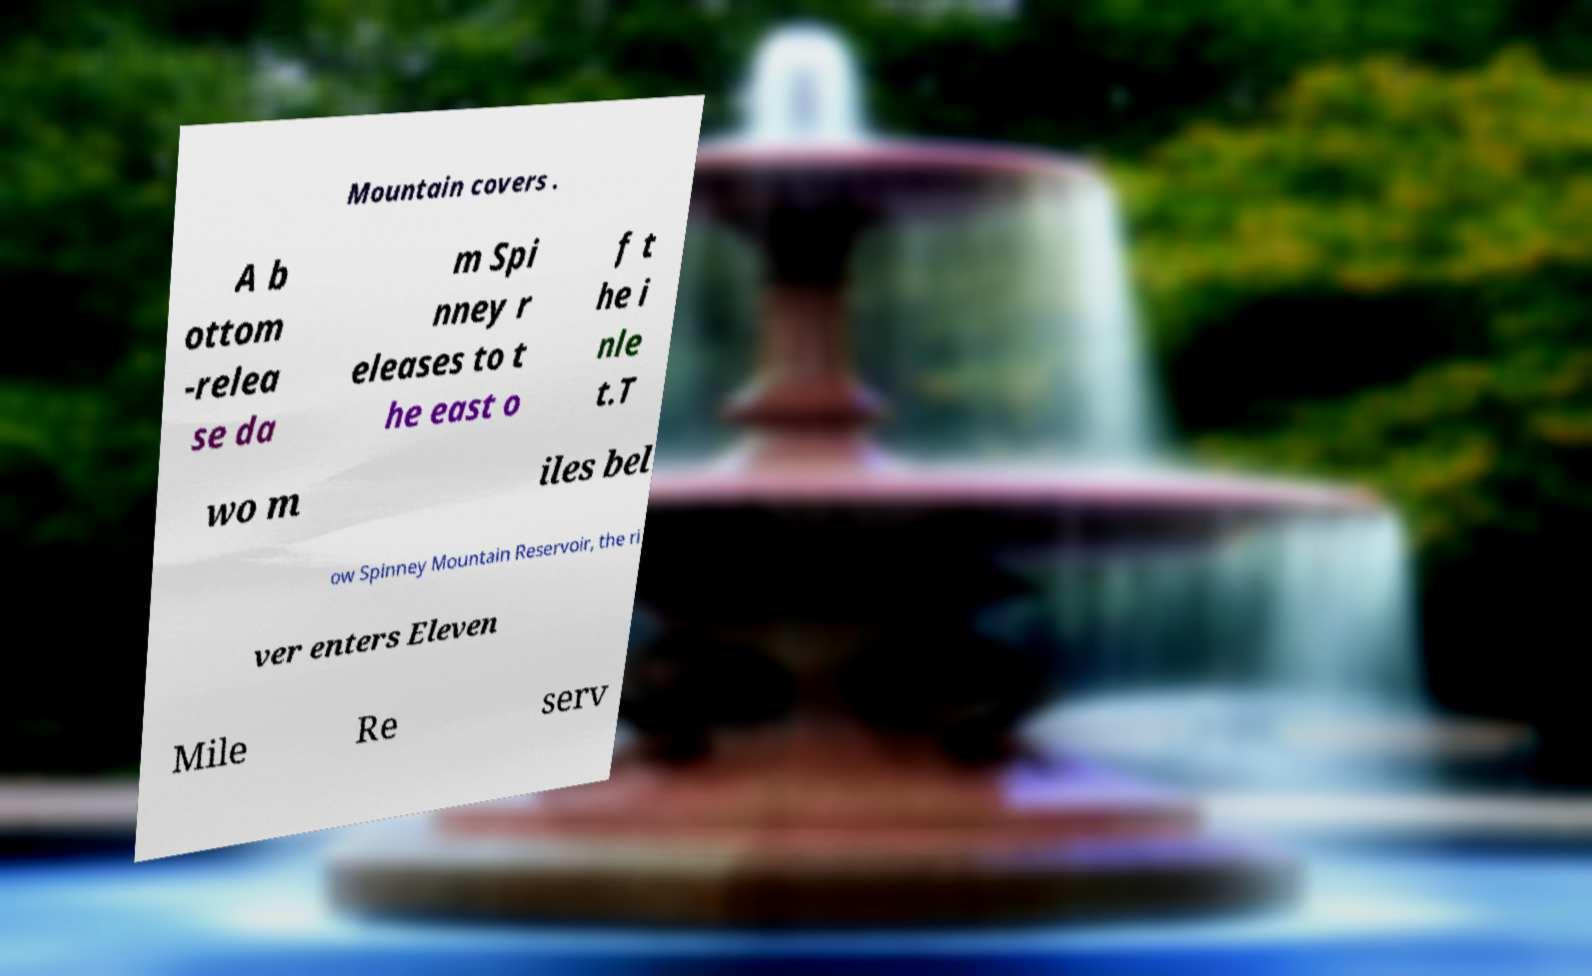Could you extract and type out the text from this image? Mountain covers . A b ottom -relea se da m Spi nney r eleases to t he east o f t he i nle t.T wo m iles bel ow Spinney Mountain Reservoir, the ri ver enters Eleven Mile Re serv 